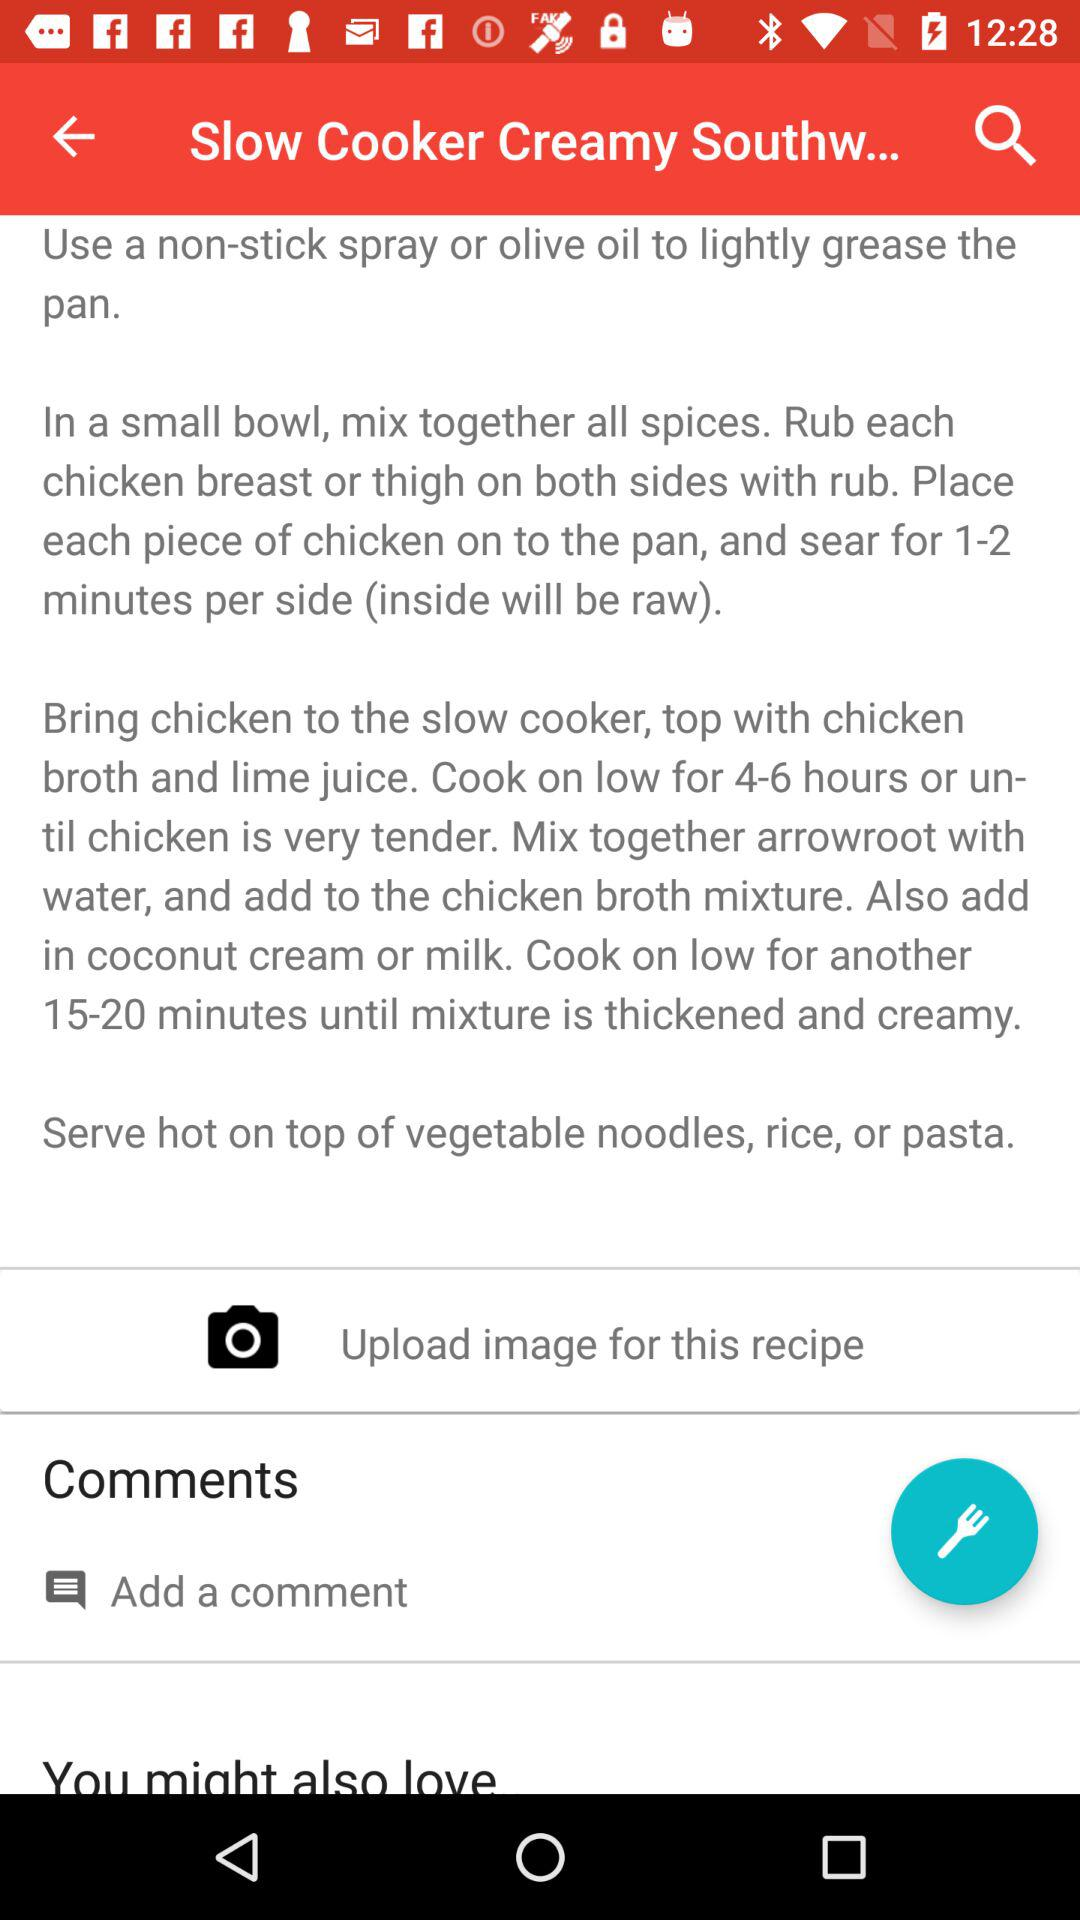For how many hours is chicken cooked at a low flame for tendering?
When the provided information is insufficient, respond with <no answer>. <no answer> 